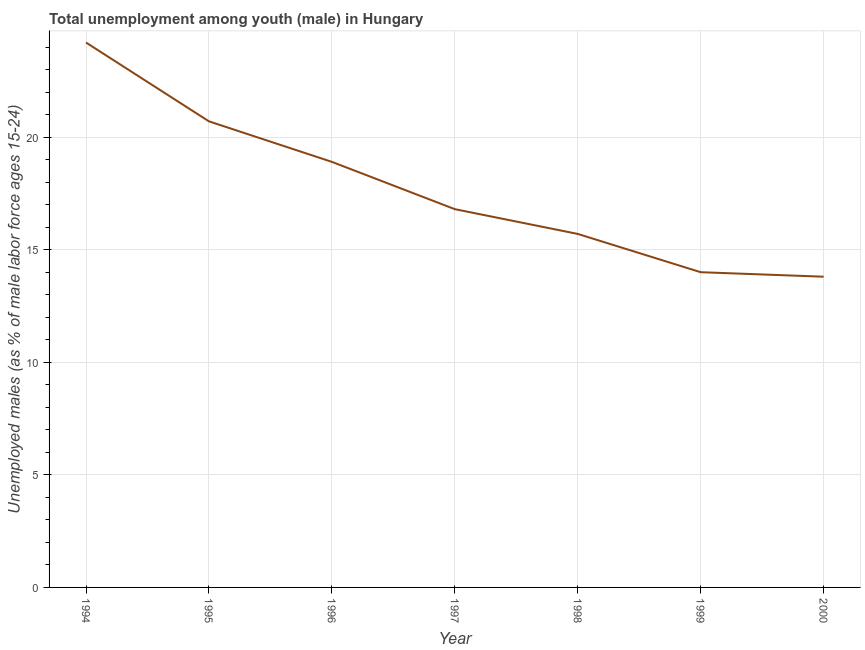What is the unemployed male youth population in 1995?
Your response must be concise. 20.7. Across all years, what is the maximum unemployed male youth population?
Your response must be concise. 24.2. Across all years, what is the minimum unemployed male youth population?
Your answer should be very brief. 13.8. In which year was the unemployed male youth population maximum?
Provide a short and direct response. 1994. What is the sum of the unemployed male youth population?
Provide a short and direct response. 124.1. What is the difference between the unemployed male youth population in 1995 and 1999?
Offer a terse response. 6.7. What is the average unemployed male youth population per year?
Provide a short and direct response. 17.73. What is the median unemployed male youth population?
Your response must be concise. 16.8. In how many years, is the unemployed male youth population greater than 8 %?
Your response must be concise. 7. Do a majority of the years between 1999 and 2000 (inclusive) have unemployed male youth population greater than 23 %?
Your answer should be compact. No. What is the ratio of the unemployed male youth population in 1994 to that in 1999?
Keep it short and to the point. 1.73. Is the unemployed male youth population in 1994 less than that in 1998?
Your answer should be compact. No. Is the sum of the unemployed male youth population in 1994 and 1999 greater than the maximum unemployed male youth population across all years?
Give a very brief answer. Yes. What is the difference between the highest and the lowest unemployed male youth population?
Give a very brief answer. 10.4. Does the unemployed male youth population monotonically increase over the years?
Your answer should be very brief. No. How many years are there in the graph?
Your answer should be compact. 7. What is the difference between two consecutive major ticks on the Y-axis?
Give a very brief answer. 5. Does the graph contain any zero values?
Provide a succinct answer. No. Does the graph contain grids?
Your answer should be compact. Yes. What is the title of the graph?
Ensure brevity in your answer.  Total unemployment among youth (male) in Hungary. What is the label or title of the X-axis?
Give a very brief answer. Year. What is the label or title of the Y-axis?
Make the answer very short. Unemployed males (as % of male labor force ages 15-24). What is the Unemployed males (as % of male labor force ages 15-24) in 1994?
Ensure brevity in your answer.  24.2. What is the Unemployed males (as % of male labor force ages 15-24) of 1995?
Your answer should be very brief. 20.7. What is the Unemployed males (as % of male labor force ages 15-24) in 1996?
Offer a terse response. 18.9. What is the Unemployed males (as % of male labor force ages 15-24) of 1997?
Give a very brief answer. 16.8. What is the Unemployed males (as % of male labor force ages 15-24) of 1998?
Your answer should be very brief. 15.7. What is the Unemployed males (as % of male labor force ages 15-24) of 1999?
Your answer should be very brief. 14. What is the Unemployed males (as % of male labor force ages 15-24) in 2000?
Provide a succinct answer. 13.8. What is the difference between the Unemployed males (as % of male labor force ages 15-24) in 1994 and 1995?
Your response must be concise. 3.5. What is the difference between the Unemployed males (as % of male labor force ages 15-24) in 1994 and 1996?
Your response must be concise. 5.3. What is the difference between the Unemployed males (as % of male labor force ages 15-24) in 1994 and 1998?
Provide a short and direct response. 8.5. What is the difference between the Unemployed males (as % of male labor force ages 15-24) in 1995 and 1996?
Provide a succinct answer. 1.8. What is the difference between the Unemployed males (as % of male labor force ages 15-24) in 1995 and 1997?
Offer a very short reply. 3.9. What is the difference between the Unemployed males (as % of male labor force ages 15-24) in 1995 and 1998?
Offer a very short reply. 5. What is the difference between the Unemployed males (as % of male labor force ages 15-24) in 1996 and 1997?
Your response must be concise. 2.1. What is the difference between the Unemployed males (as % of male labor force ages 15-24) in 1996 and 1998?
Offer a very short reply. 3.2. What is the difference between the Unemployed males (as % of male labor force ages 15-24) in 1996 and 1999?
Keep it short and to the point. 4.9. What is the difference between the Unemployed males (as % of male labor force ages 15-24) in 1997 and 1998?
Your response must be concise. 1.1. What is the difference between the Unemployed males (as % of male labor force ages 15-24) in 1997 and 2000?
Give a very brief answer. 3. What is the difference between the Unemployed males (as % of male labor force ages 15-24) in 1998 and 1999?
Provide a succinct answer. 1.7. What is the difference between the Unemployed males (as % of male labor force ages 15-24) in 1999 and 2000?
Provide a short and direct response. 0.2. What is the ratio of the Unemployed males (as % of male labor force ages 15-24) in 1994 to that in 1995?
Provide a succinct answer. 1.17. What is the ratio of the Unemployed males (as % of male labor force ages 15-24) in 1994 to that in 1996?
Ensure brevity in your answer.  1.28. What is the ratio of the Unemployed males (as % of male labor force ages 15-24) in 1994 to that in 1997?
Offer a very short reply. 1.44. What is the ratio of the Unemployed males (as % of male labor force ages 15-24) in 1994 to that in 1998?
Make the answer very short. 1.54. What is the ratio of the Unemployed males (as % of male labor force ages 15-24) in 1994 to that in 1999?
Ensure brevity in your answer.  1.73. What is the ratio of the Unemployed males (as % of male labor force ages 15-24) in 1994 to that in 2000?
Provide a short and direct response. 1.75. What is the ratio of the Unemployed males (as % of male labor force ages 15-24) in 1995 to that in 1996?
Offer a terse response. 1.09. What is the ratio of the Unemployed males (as % of male labor force ages 15-24) in 1995 to that in 1997?
Make the answer very short. 1.23. What is the ratio of the Unemployed males (as % of male labor force ages 15-24) in 1995 to that in 1998?
Give a very brief answer. 1.32. What is the ratio of the Unemployed males (as % of male labor force ages 15-24) in 1995 to that in 1999?
Offer a very short reply. 1.48. What is the ratio of the Unemployed males (as % of male labor force ages 15-24) in 1995 to that in 2000?
Offer a very short reply. 1.5. What is the ratio of the Unemployed males (as % of male labor force ages 15-24) in 1996 to that in 1998?
Your answer should be compact. 1.2. What is the ratio of the Unemployed males (as % of male labor force ages 15-24) in 1996 to that in 1999?
Offer a very short reply. 1.35. What is the ratio of the Unemployed males (as % of male labor force ages 15-24) in 1996 to that in 2000?
Provide a succinct answer. 1.37. What is the ratio of the Unemployed males (as % of male labor force ages 15-24) in 1997 to that in 1998?
Offer a terse response. 1.07. What is the ratio of the Unemployed males (as % of male labor force ages 15-24) in 1997 to that in 2000?
Provide a succinct answer. 1.22. What is the ratio of the Unemployed males (as % of male labor force ages 15-24) in 1998 to that in 1999?
Your answer should be very brief. 1.12. What is the ratio of the Unemployed males (as % of male labor force ages 15-24) in 1998 to that in 2000?
Your answer should be compact. 1.14. What is the ratio of the Unemployed males (as % of male labor force ages 15-24) in 1999 to that in 2000?
Offer a terse response. 1.01. 